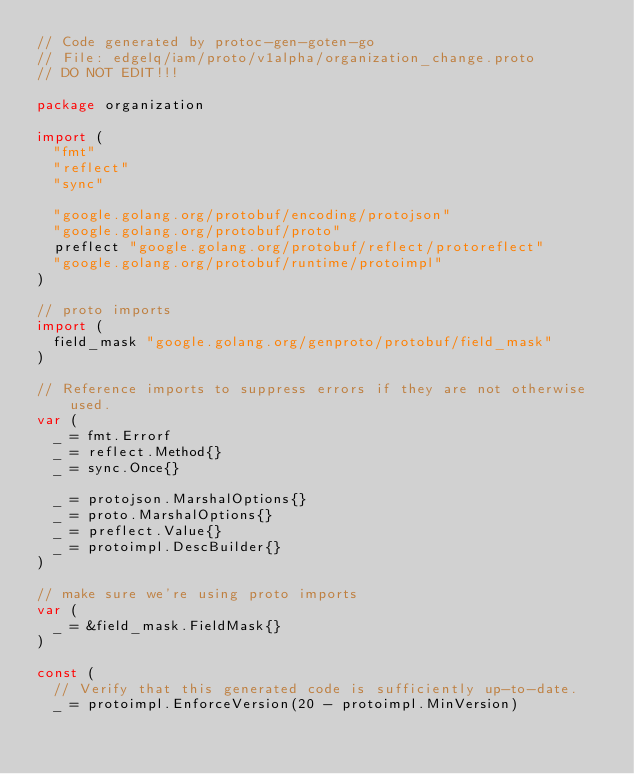<code> <loc_0><loc_0><loc_500><loc_500><_Go_>// Code generated by protoc-gen-goten-go
// File: edgelq/iam/proto/v1alpha/organization_change.proto
// DO NOT EDIT!!!

package organization

import (
	"fmt"
	"reflect"
	"sync"

	"google.golang.org/protobuf/encoding/protojson"
	"google.golang.org/protobuf/proto"
	preflect "google.golang.org/protobuf/reflect/protoreflect"
	"google.golang.org/protobuf/runtime/protoimpl"
)

// proto imports
import (
	field_mask "google.golang.org/genproto/protobuf/field_mask"
)

// Reference imports to suppress errors if they are not otherwise used.
var (
	_ = fmt.Errorf
	_ = reflect.Method{}
	_ = sync.Once{}

	_ = protojson.MarshalOptions{}
	_ = proto.MarshalOptions{}
	_ = preflect.Value{}
	_ = protoimpl.DescBuilder{}
)

// make sure we're using proto imports
var (
	_ = &field_mask.FieldMask{}
)

const (
	// Verify that this generated code is sufficiently up-to-date.
	_ = protoimpl.EnforceVersion(20 - protoimpl.MinVersion)</code> 